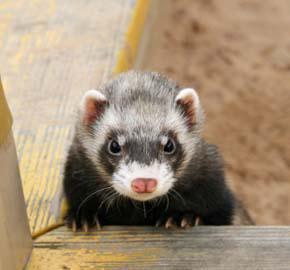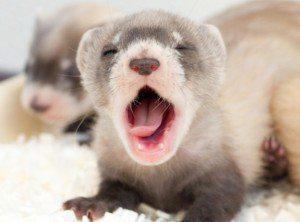The first image is the image on the left, the second image is the image on the right. For the images displayed, is the sentence "The right image depicts more ferrets than the left image." factually correct? Answer yes or no. Yes. 